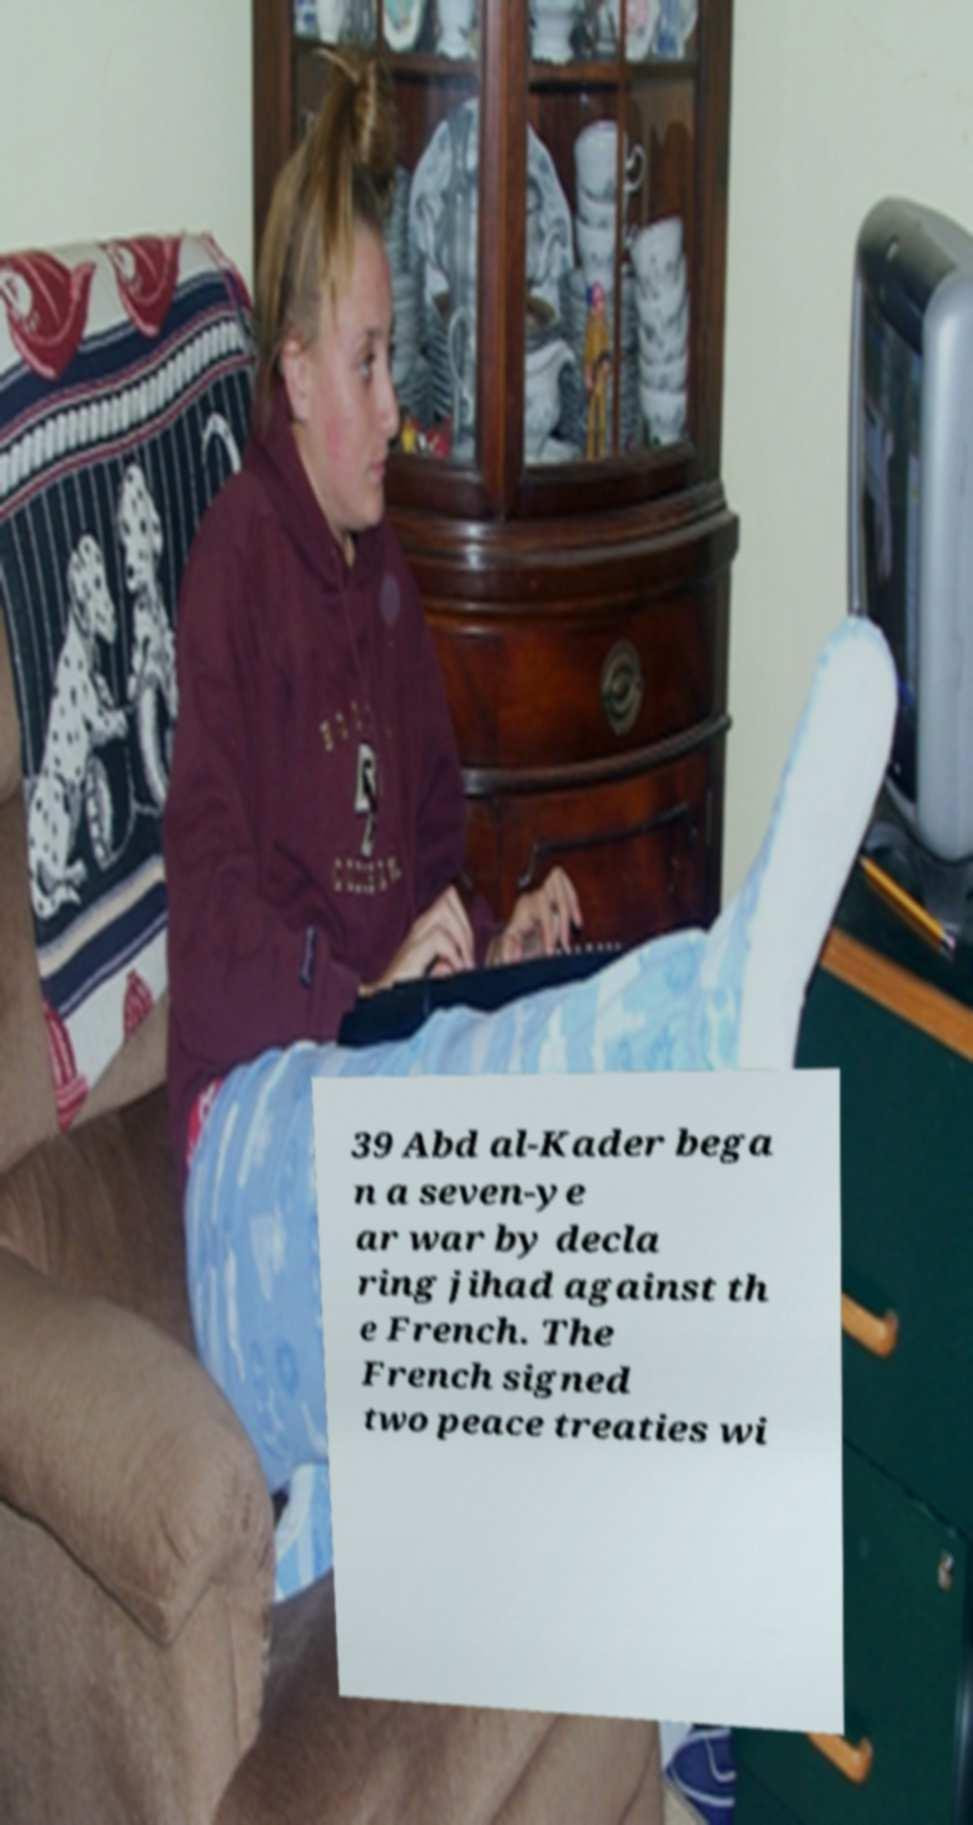Could you assist in decoding the text presented in this image and type it out clearly? 39 Abd al-Kader bega n a seven-ye ar war by decla ring jihad against th e French. The French signed two peace treaties wi 